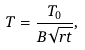Convert formula to latex. <formula><loc_0><loc_0><loc_500><loc_500>T = \frac { T _ { 0 } } { B \sqrt { r t } } ,</formula> 